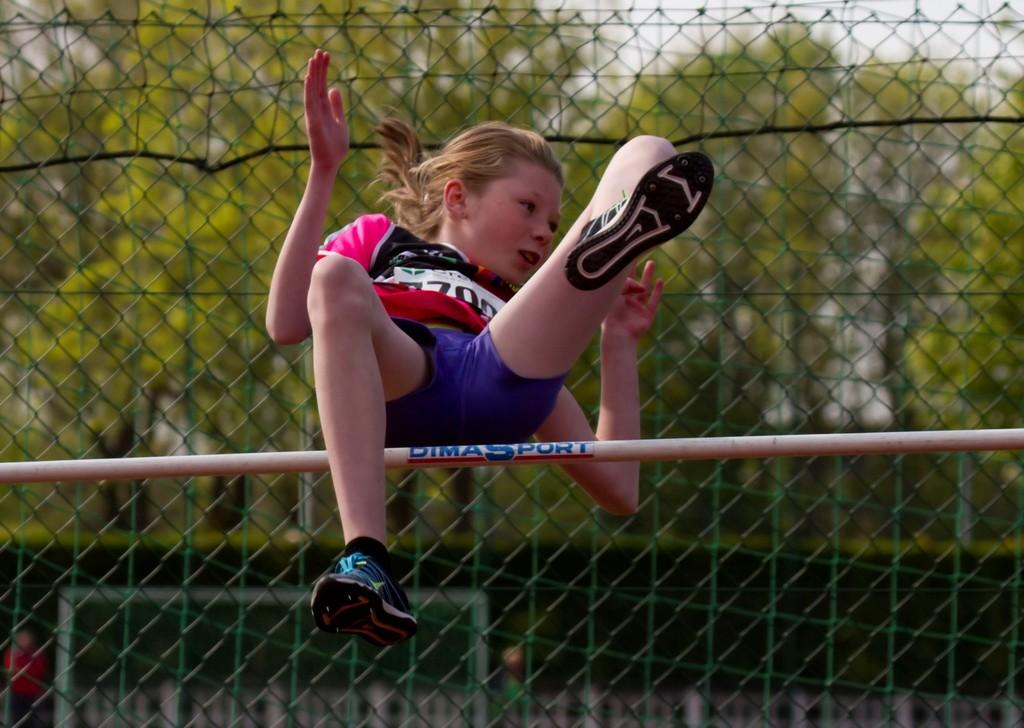What is the main subject in the foreground of the image? There is a girl in the foreground of the image. What is the girl doing in the image? The girl is jumping over a stick in the image. How high is the girl in the air? The girl is in the air, but the exact height cannot be determined from the image. What can be seen in the background of the image? There is a fencing and greenery behind the fencing in the background of the image. What is visible above the fencing and greenery? The sky is visible in the background of the image. What type of quartz can be seen on the girl's shoes in the image? There is no quartz visible on the girl's shoes in the image. What position does the tin hold in the image? There is no tin present in the image. 